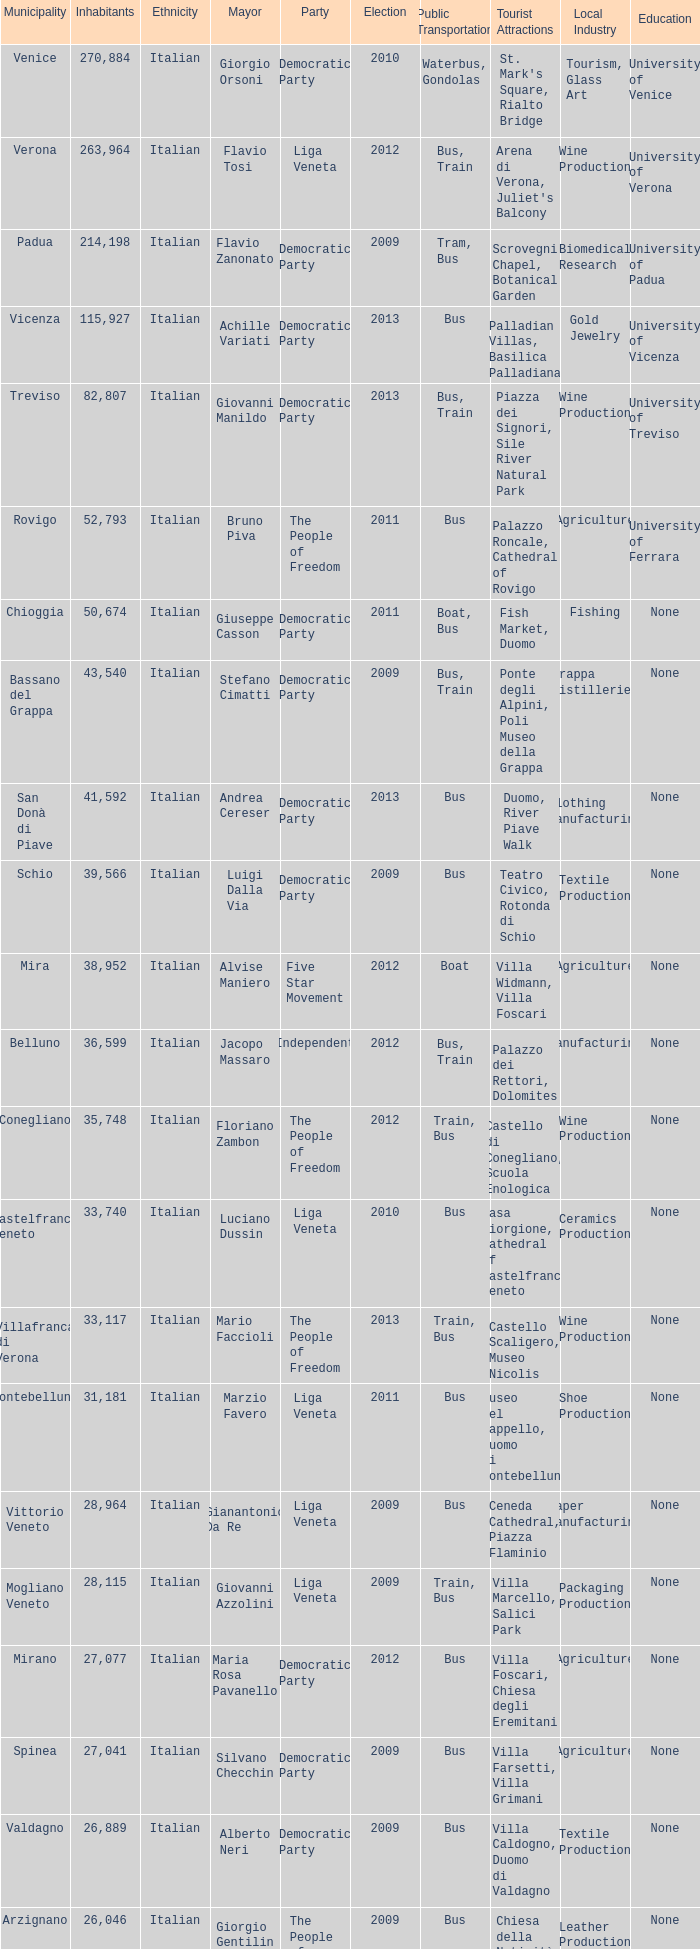What party was achille variati afilliated with? Democratic Party. 